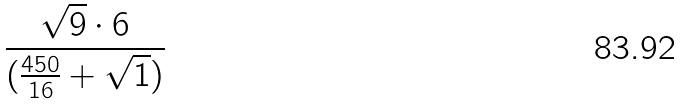<formula> <loc_0><loc_0><loc_500><loc_500>\frac { \sqrt { 9 } \cdot 6 } { ( \frac { 4 5 0 } { 1 6 } + \sqrt { 1 } ) }</formula> 